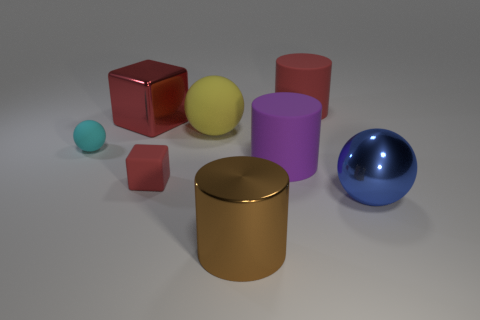There is a thing that is on the left side of the small red cube and behind the small sphere; what is its color?
Provide a short and direct response. Red. Is there a gray object that has the same shape as the big blue metallic object?
Give a very brief answer. No. Is the color of the shiny cube the same as the big matte sphere?
Your answer should be very brief. No. Are there any large metallic balls that are on the left side of the small matte object in front of the small cyan rubber sphere?
Give a very brief answer. No. How many objects are either rubber cylinders that are behind the tiny ball or large objects to the left of the purple rubber thing?
Offer a very short reply. 4. What number of things are cylinders or big cylinders that are in front of the blue shiny object?
Give a very brief answer. 3. There is a red thing that is to the right of the red matte object that is in front of the large red rubber thing that is behind the small sphere; how big is it?
Offer a very short reply. Large. There is a cube that is the same size as the purple cylinder; what is its material?
Provide a short and direct response. Metal. Is there a yellow shiny object of the same size as the cyan thing?
Give a very brief answer. No. Is the size of the shiny object that is to the right of the brown shiny cylinder the same as the cyan rubber ball?
Your response must be concise. No. 